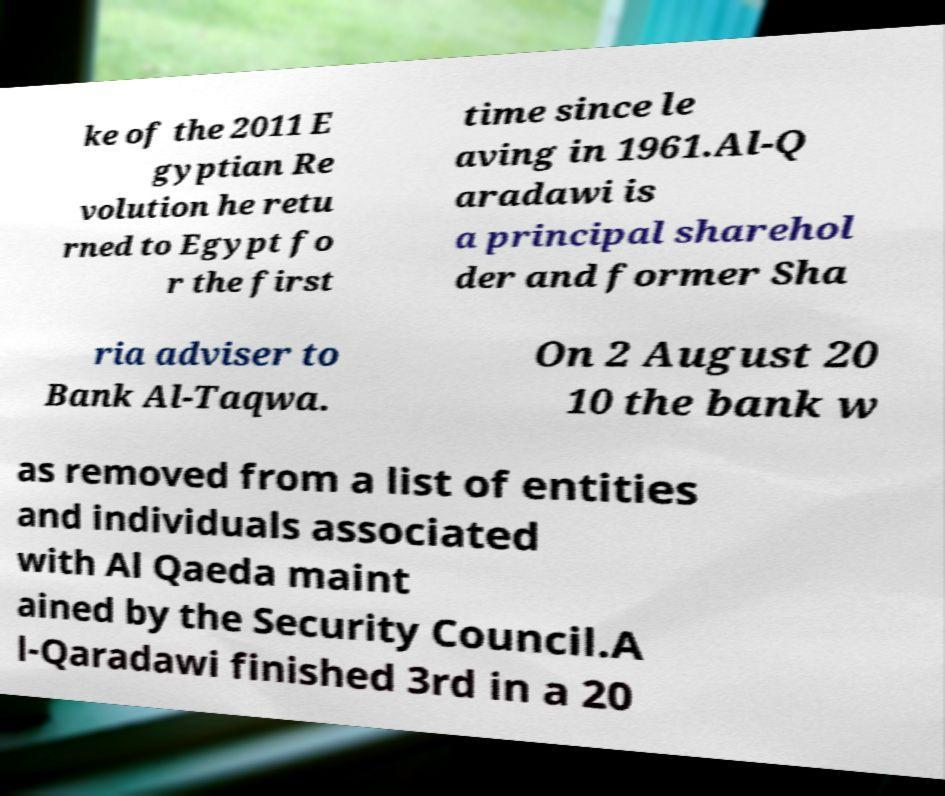Please identify and transcribe the text found in this image. ke of the 2011 E gyptian Re volution he retu rned to Egypt fo r the first time since le aving in 1961.Al-Q aradawi is a principal sharehol der and former Sha ria adviser to Bank Al-Taqwa. On 2 August 20 10 the bank w as removed from a list of entities and individuals associated with Al Qaeda maint ained by the Security Council.A l-Qaradawi finished 3rd in a 20 